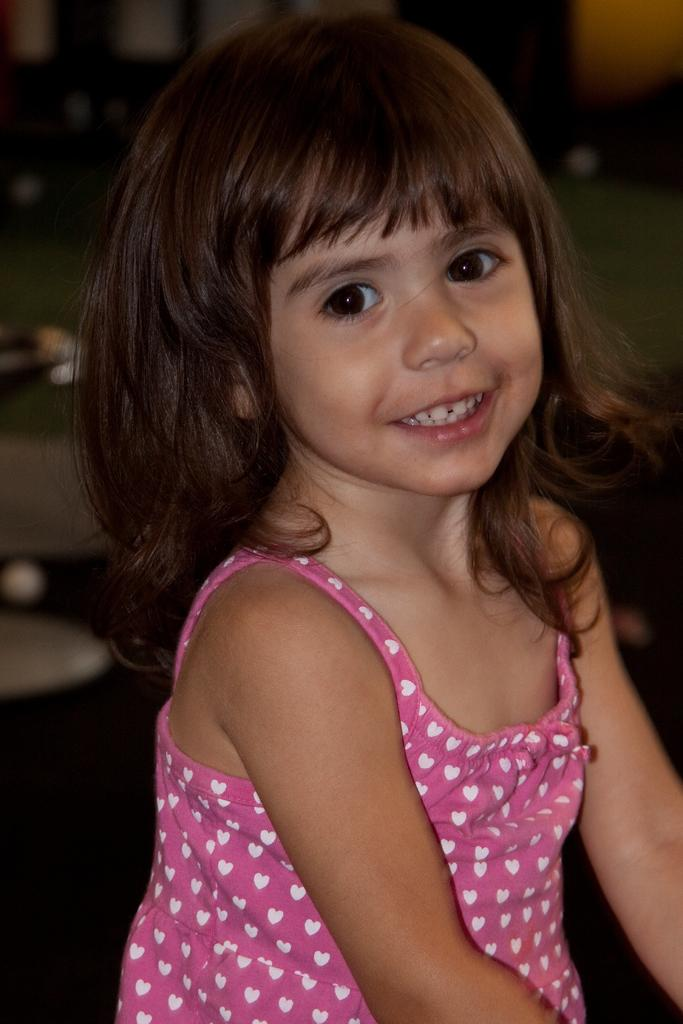Who is present in the image? There is a girl in the image. What expression does the girl have? The girl is smiling. What type of wall can be seen in the image? There is no wall present in the image; it only features a girl. Does the girl have the ability to push the wall in the image? There is no wall present in the image, so the question of the girl pushing it is not applicable. 